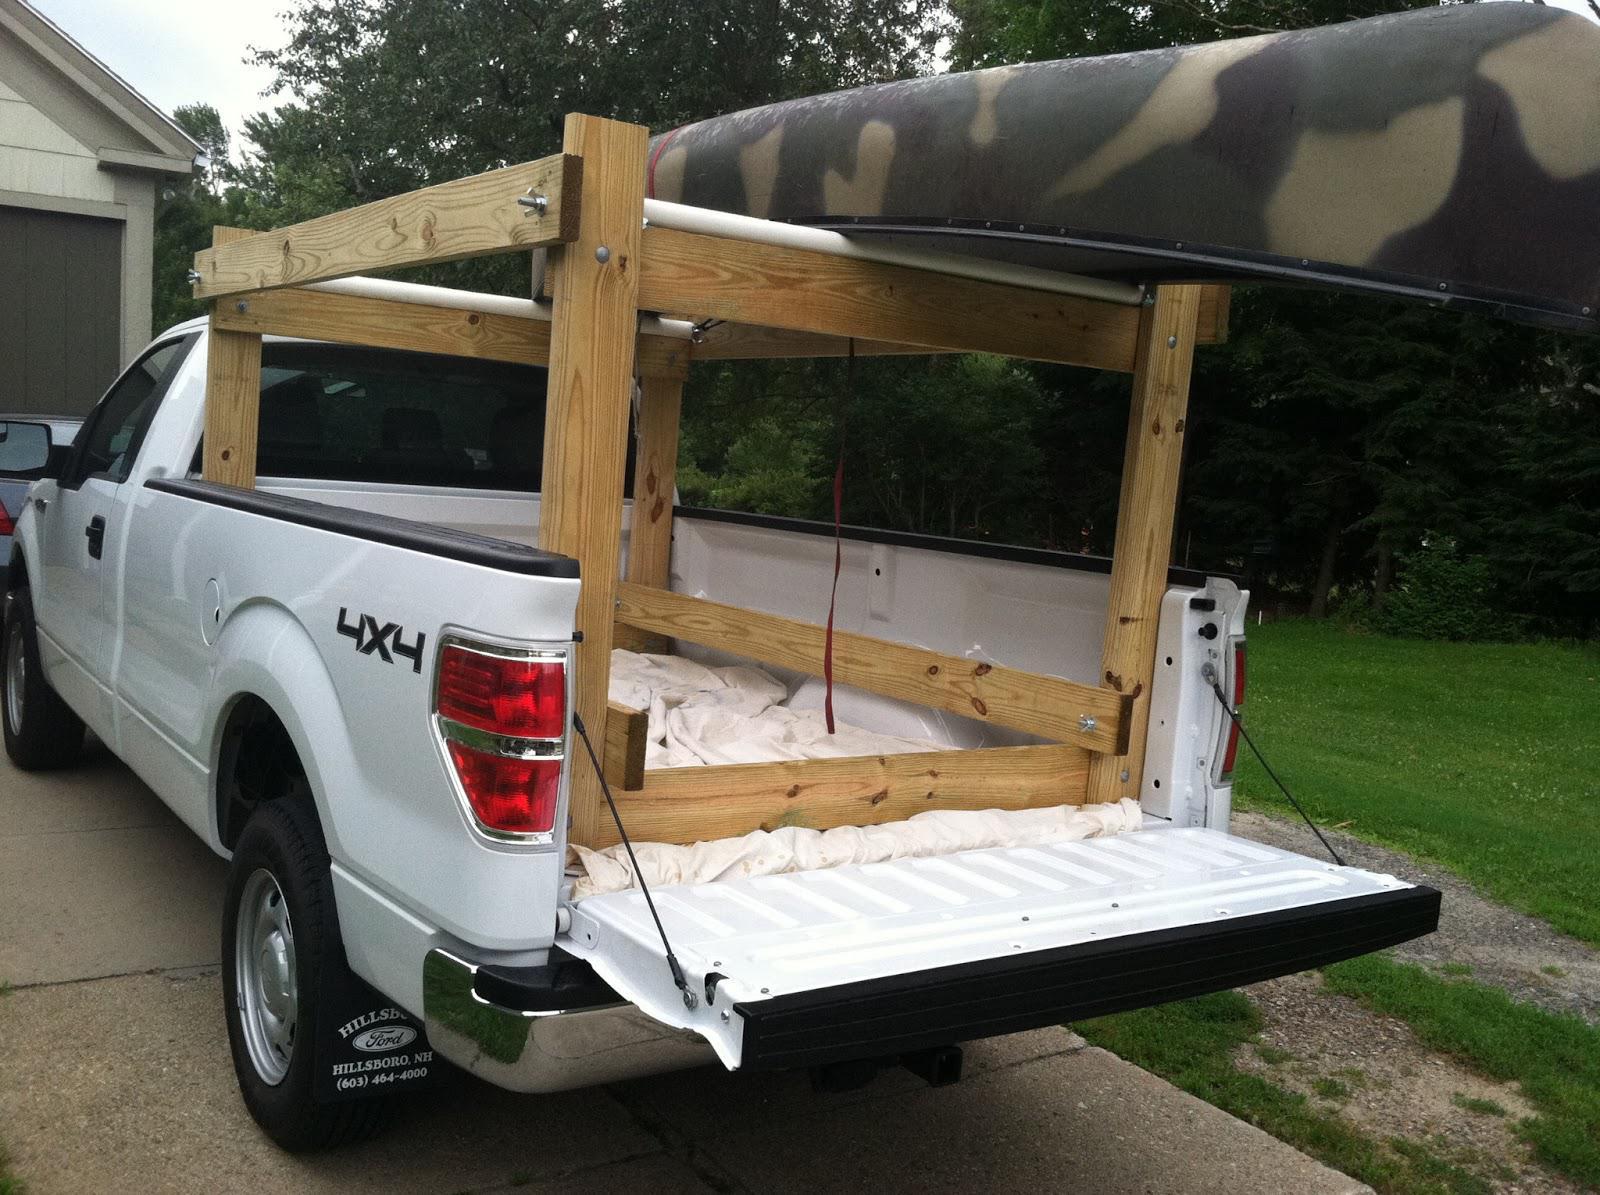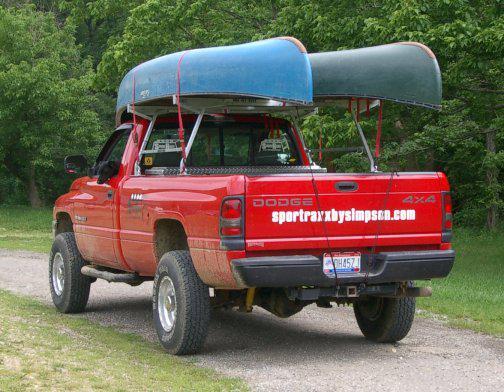The first image is the image on the left, the second image is the image on the right. For the images shown, is this caption "In one image, a pickup truck has two different-colored boats loaded on an overhead rack." true? Answer yes or no. Yes. 